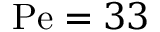Convert formula to latex. <formula><loc_0><loc_0><loc_500><loc_500>P e = 3 3</formula> 